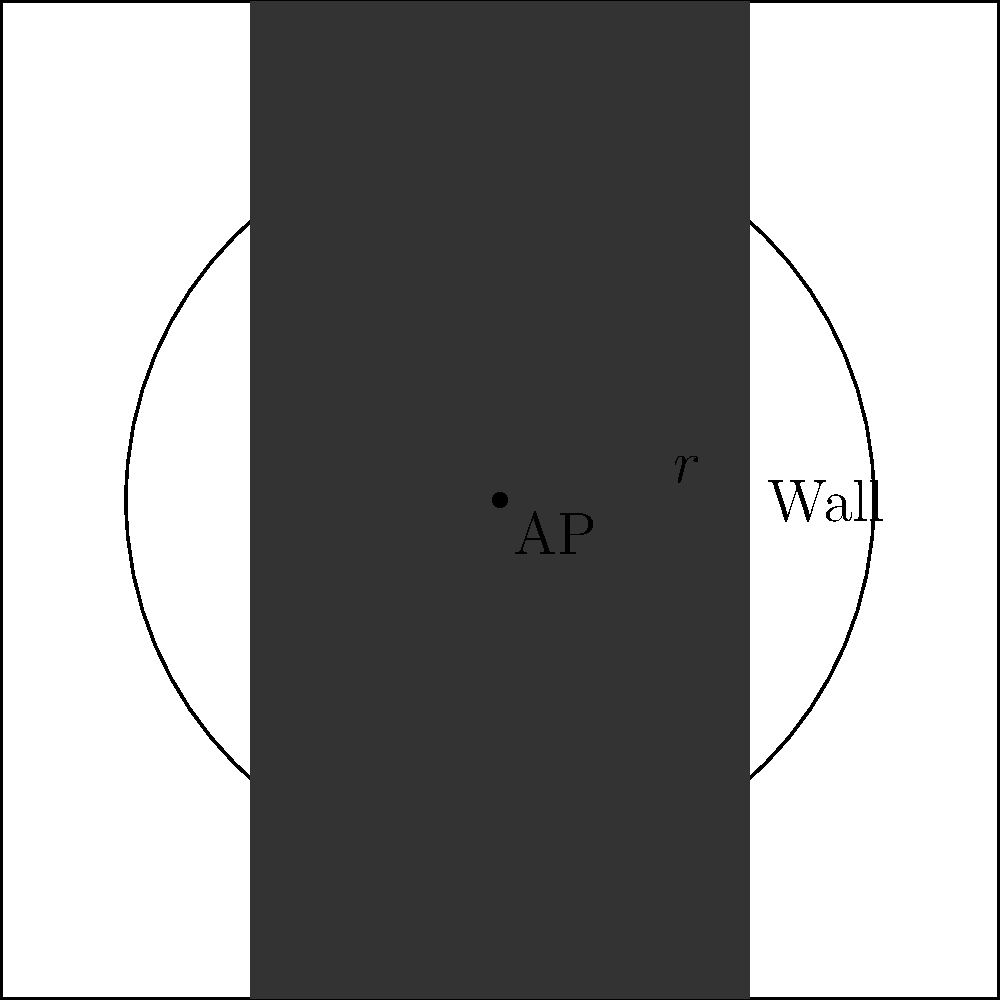A Wi-Fi access point (AP) is placed in a square room with sides of 8 meters. The AP has a circular coverage range of 6 meters in radius. However, there's a wall running through the middle of the room, parallel to two of the sides, which blocks the Wi-Fi signal. If the wall reduces the signal strength by 50% on the other side, what is the total area (in square meters) that receives at least 50% of the original signal strength? To solve this problem, we need to follow these steps:

1) First, calculate the area of the full circle:
   $$A_{circle} = \pi r^2 = \pi (6m)^2 = 36\pi m^2$$

2) The wall divides the room into two equal halves. We need to find the area of the half-circle on the AP's side of the wall:
   $$A_{half-circle} = \frac{1}{2} \pi r^2 = \frac{1}{2} (36\pi) m^2 = 18\pi m^2$$

3) Now, we need to check if this half-circle extends beyond the room's boundaries. The room is 8m x 8m, so each half is 4m wide.

4) The radius (6m) is greater than the half-room width (4m), so we need to calculate the area of the circular segment that falls within the room.

5) To do this, we can use the formula for a circular segment's area:
   $$A_{segment} = r^2 \arccos(\frac{a}{r}) - a\sqrt{r^2 - a^2}$$
   where $a$ is the distance from the center to the chord (in this case, 4m).

6) Plugging in the values:
   $$A_{segment} = 6^2 \arccos(\frac{4}{6}) - 4\sqrt{6^2 - 4^2}$$
   $$= 36 \arccos(\frac{2}{3}) - 4\sqrt{20}$$
   $$\approx 26.73 m^2$$

7) The total area receiving at least 50% signal strength is this segment area:
   $$A_{total} \approx 26.73 m^2$$
Answer: $26.73 m^2$ 